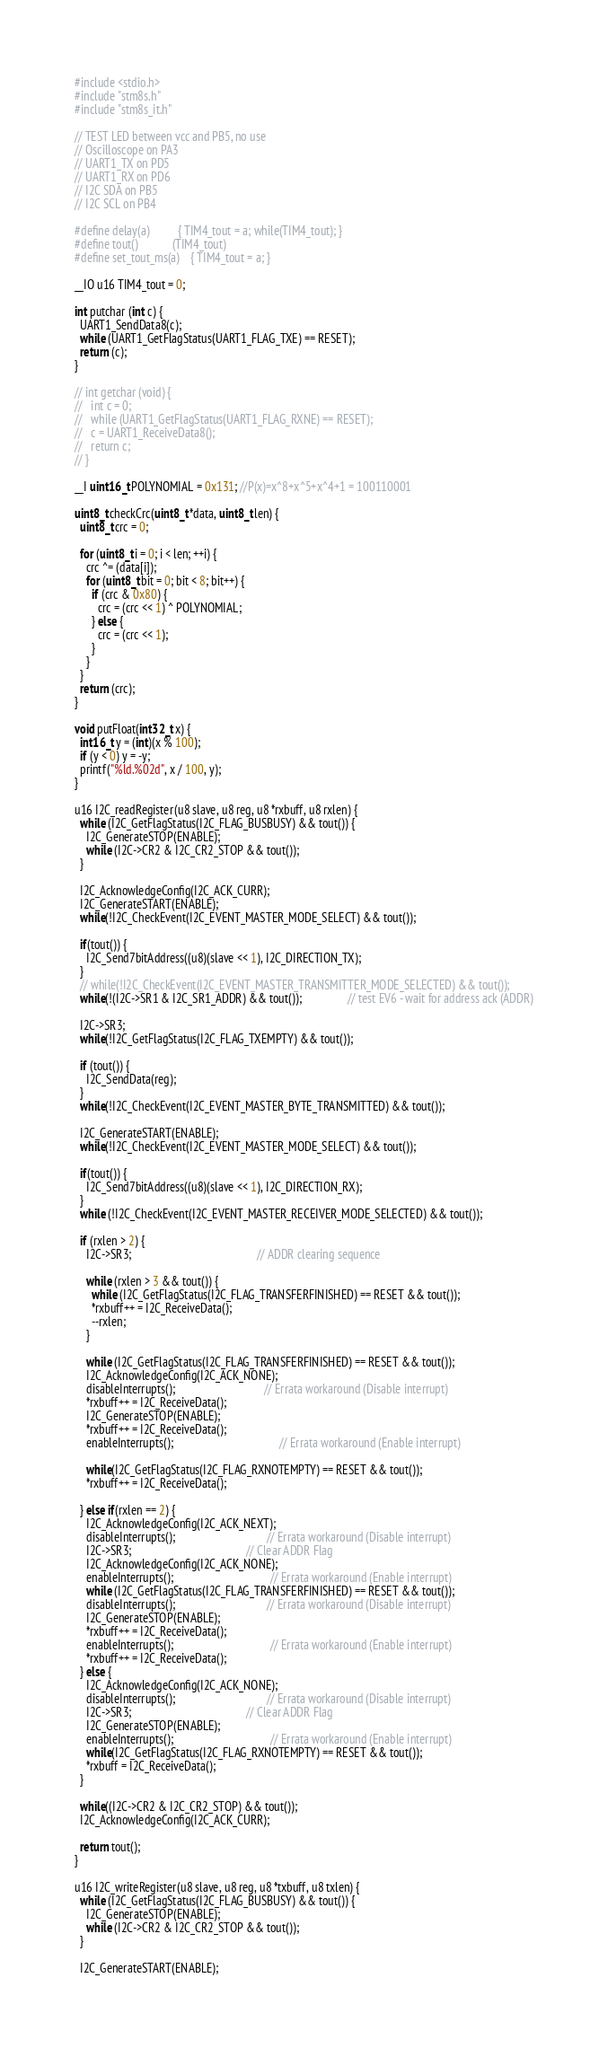Convert code to text. <code><loc_0><loc_0><loc_500><loc_500><_C_>#include <stdio.h>
#include "stm8s.h"
#include "stm8s_it.h"

// TEST LED between vcc and PB5, no use
// Oscilloscope on PA3
// UART1_TX on PD5
// UART1_RX on PD6
// I2C SDA on PB5
// I2C SCL on PB4

#define delay(a)          { TIM4_tout = a; while(TIM4_tout); }
#define tout()            (TIM4_tout)
#define set_tout_ms(a)    { TIM4_tout = a; }

__IO u16 TIM4_tout = 0;

int putchar (int c) {
  UART1_SendData8(c);
  while (UART1_GetFlagStatus(UART1_FLAG_TXE) == RESET);
  return (c);
}

// int getchar (void) {
//   int c = 0;
//   while (UART1_GetFlagStatus(UART1_FLAG_RXNE) == RESET);
//   c = UART1_ReceiveData8();
//   return c;
// }

__I uint16_t POLYNOMIAL = 0x131; //P(x)=x^8+x^5+x^4+1 = 100110001

uint8_t checkCrc(uint8_t *data, uint8_t len) {
  uint8_t crc = 0;

  for (uint8_t i = 0; i < len; ++i) {
    crc ^= (data[i]);
    for (uint8_t bit = 0; bit < 8; bit++) {
      if (crc & 0x80) {
        crc = (crc << 1) ^ POLYNOMIAL;
      } else {
        crc = (crc << 1);
      }
    }
  }
  return (crc);
}

void putFloat(int32_t x) {
  int16_t y = (int)(x % 100);
  if (y < 0) y = -y;
  printf("%ld.%02d", x / 100, y);
}

u16 I2C_readRegister(u8 slave, u8 reg, u8 *rxbuff, u8 rxlen) {
  while (I2C_GetFlagStatus(I2C_FLAG_BUSBUSY) && tout()) {
    I2C_GenerateSTOP(ENABLE);
    while (I2C->CR2 & I2C_CR2_STOP && tout());
  }

  I2C_AcknowledgeConfig(I2C_ACK_CURR);
  I2C_GenerateSTART(ENABLE);
  while(!I2C_CheckEvent(I2C_EVENT_MASTER_MODE_SELECT) && tout());

  if(tout()) {
    I2C_Send7bitAddress((u8)(slave << 1), I2C_DIRECTION_TX);
  }
  // while(!I2C_CheckEvent(I2C_EVENT_MASTER_TRANSMITTER_MODE_SELECTED) && tout());
  while(!(I2C->SR1 & I2C_SR1_ADDR) && tout()); 				// test EV6 - wait for address ack (ADDR)

  I2C->SR3;
  while(!I2C_GetFlagStatus(I2C_FLAG_TXEMPTY) && tout());

  if (tout()) {
    I2C_SendData(reg);
  }
  while(!I2C_CheckEvent(I2C_EVENT_MASTER_BYTE_TRANSMITTED) && tout());

  I2C_GenerateSTART(ENABLE);
  while(!I2C_CheckEvent(I2C_EVENT_MASTER_MODE_SELECT) && tout());

  if(tout()) {
    I2C_Send7bitAddress((u8)(slave << 1), I2C_DIRECTION_RX);
  }
  while (!I2C_CheckEvent(I2C_EVENT_MASTER_RECEIVER_MODE_SELECTED) && tout());

  if (rxlen > 2) {
    I2C->SR3;                                            // ADDR clearing sequence

    while (rxlen > 3 && tout()) {
      while (I2C_GetFlagStatus(I2C_FLAG_TRANSFERFINISHED) == RESET && tout());
      *rxbuff++ = I2C_ReceiveData();
      --rxlen;
    }

    while (I2C_GetFlagStatus(I2C_FLAG_TRANSFERFINISHED) == RESET && tout());
    I2C_AcknowledgeConfig(I2C_ACK_NONE);
    disableInterrupts();                               // Errata workaround (Disable interrupt)
    *rxbuff++ = I2C_ReceiveData();
    I2C_GenerateSTOP(ENABLE);
    *rxbuff++ = I2C_ReceiveData();
    enableInterrupts();		                             // Errata workaround (Enable interrupt)

    while(I2C_GetFlagStatus(I2C_FLAG_RXNOTEMPTY) == RESET && tout());
    *rxbuff++ = I2C_ReceiveData();

  } else if(rxlen == 2) {
    I2C_AcknowledgeConfig(I2C_ACK_NEXT);
    disableInterrupts();                          		// Errata workaround (Disable interrupt)
    I2C->SR3;                                       	// Clear ADDR Flag
    I2C_AcknowledgeConfig(I2C_ACK_NONE);
    enableInterrupts();	                              // Errata workaround (Enable interrupt)
    while (I2C_GetFlagStatus(I2C_FLAG_TRANSFERFINISHED) == RESET && tout());
    disableInterrupts();                          		// Errata workaround (Disable interrupt)
    I2C_GenerateSTOP(ENABLE);
    *rxbuff++ = I2C_ReceiveData();
    enableInterrupts();	                              // Errata workaround (Enable interrupt)
    *rxbuff++ = I2C_ReceiveData();
  } else {
    I2C_AcknowledgeConfig(I2C_ACK_NONE);
    disableInterrupts();                          		// Errata workaround (Disable interrupt)
    I2C->SR3;                                       	// Clear ADDR Flag
    I2C_GenerateSTOP(ENABLE);
    enableInterrupts();	                              // Errata workaround (Enable interrupt)
    while(I2C_GetFlagStatus(I2C_FLAG_RXNOTEMPTY) == RESET && tout());
    *rxbuff = I2C_ReceiveData();
  }

  while((I2C->CR2 & I2C_CR2_STOP) && tout());
  I2C_AcknowledgeConfig(I2C_ACK_CURR);

  return tout();
}

u16 I2C_writeRegister(u8 slave, u8 reg, u8 *txbuff, u8 txlen) {
  while (I2C_GetFlagStatus(I2C_FLAG_BUSBUSY) && tout()) {
    I2C_GenerateSTOP(ENABLE);
    while (I2C->CR2 & I2C_CR2_STOP && tout());
  }

  I2C_GenerateSTART(ENABLE);</code> 